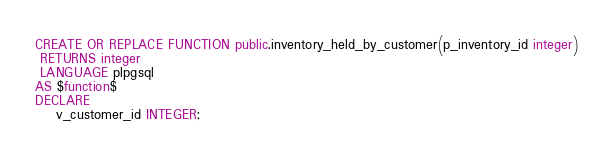Convert code to text. <code><loc_0><loc_0><loc_500><loc_500><_SQL_>CREATE OR REPLACE FUNCTION public.inventory_held_by_customer(p_inventory_id integer)
 RETURNS integer
 LANGUAGE plpgsql
AS $function$
DECLARE
    v_customer_id INTEGER;</code> 